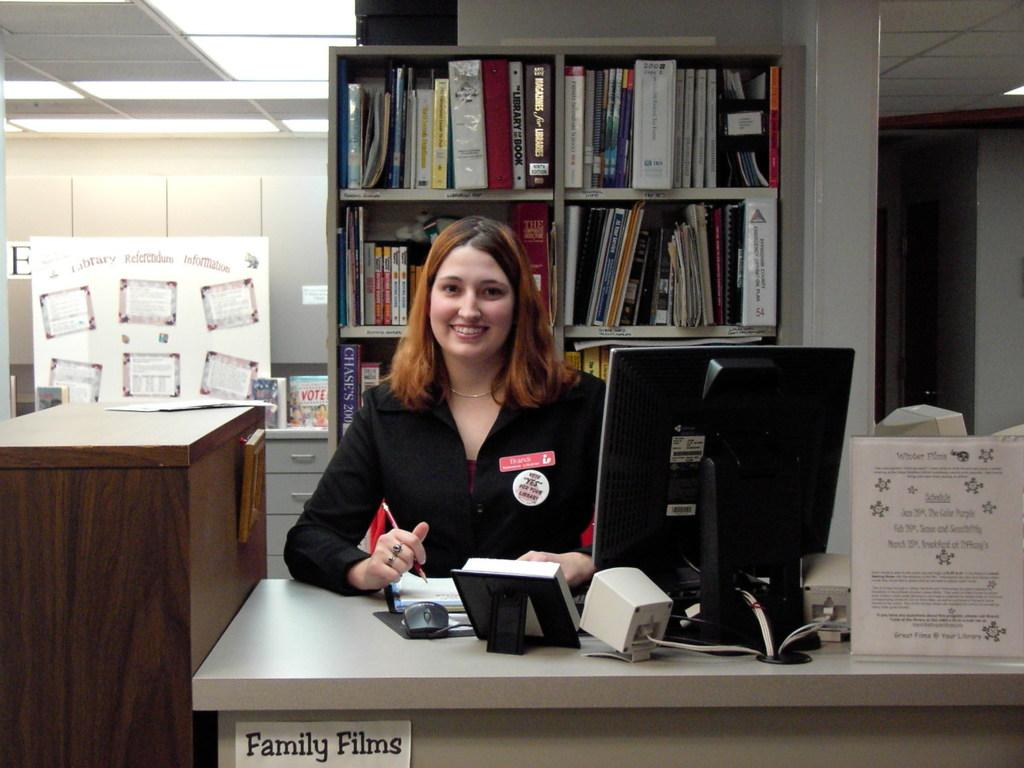<image>
Give a short and clear explanation of the subsequent image. A woman is seated at a desk that is labeled for family films. 